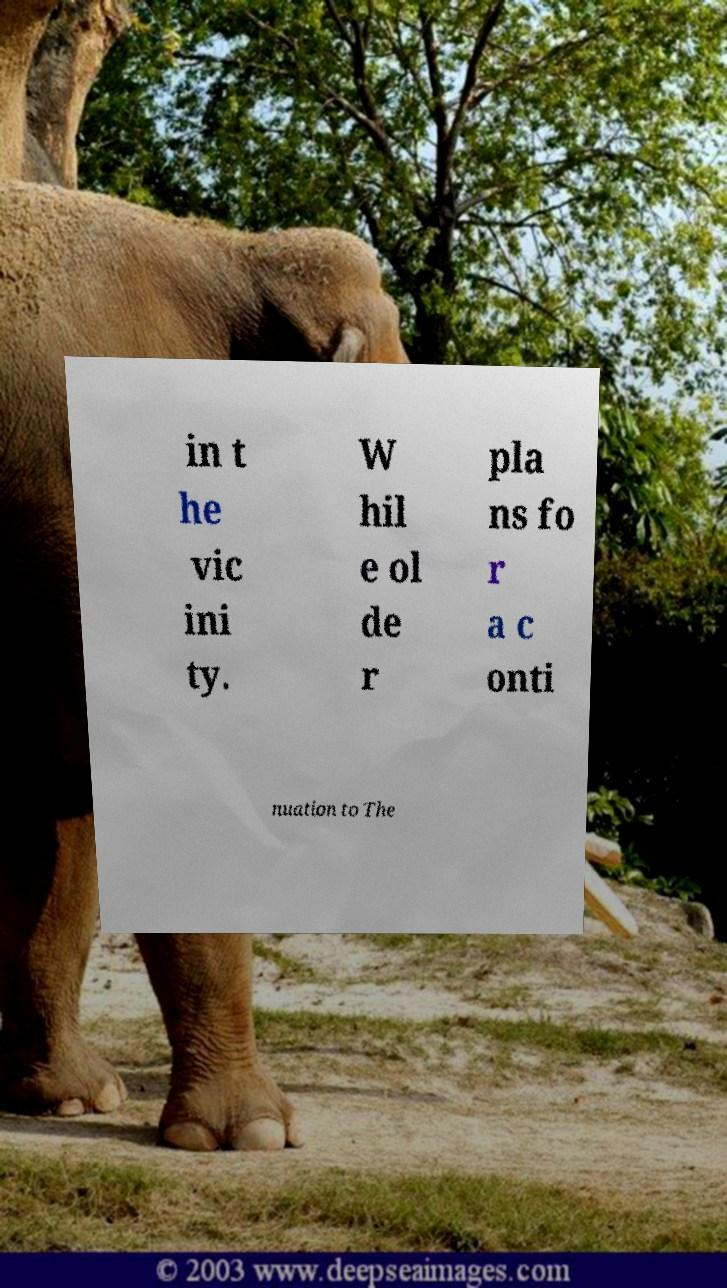Please read and relay the text visible in this image. What does it say? in t he vic ini ty. W hil e ol de r pla ns fo r a c onti nuation to The 